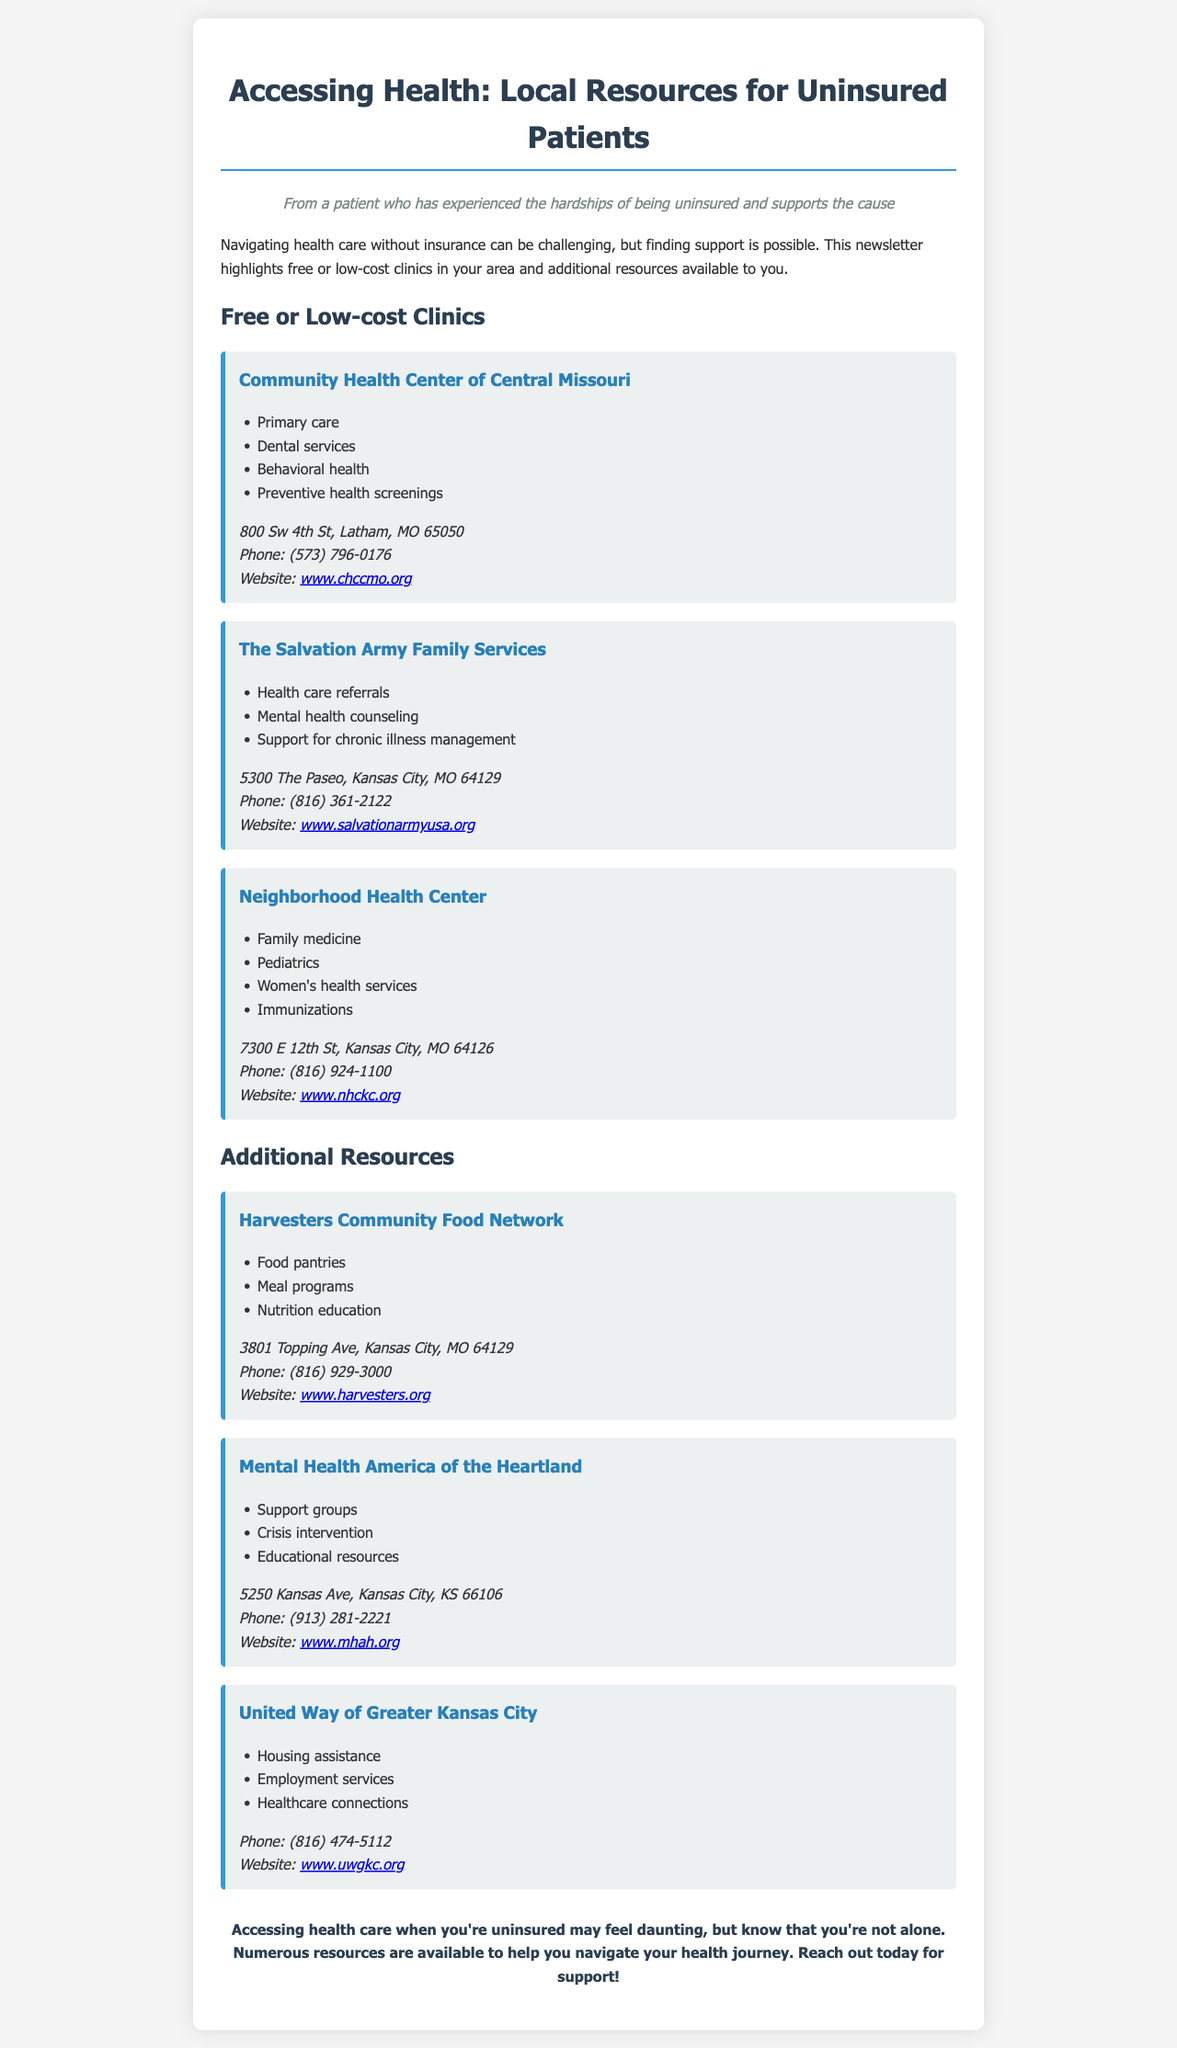what is the address of the Community Health Center of Central Missouri? The address is found in the contact information section of the document.
Answer: 800 Sw 4th St, Latham, MO 65050 what services does The Salvation Army Family Services provide? The services are listed under the clinic's description in the document.
Answer: Health care referrals, Mental health counseling, Support for chronic illness management what is the phone number for Neighborhood Health Center? The phone number is included under the contact information for the clinic.
Answer: (816) 924-1100 which organization offers food pantries? The service is identified in the section for additional resources.
Answer: Harvesters Community Food Network how many clinics are listed in the newsletter? This can be answered by counting the clinics mentioned in the section titled Free or Low-cost Clinics.
Answer: 3 what type of resources does United Way of Greater Kansas City provide? The document outlines several areas of assistance offered by the organization.
Answer: Housing assistance, Employment services, Healthcare connections what is the main theme of the newsletter? The theme is conveyed in the introduction and the closing statement of the document.
Answer: Accessing health care for uninsured patients where can I find more information about Mental Health America of the Heartland? The document provides contact details including website links under the resource section.
Answer: www.mhah.org what kind of educational initiatives does Harvesters Community Food Network offer? The initiatives are listed under its description in the additional resources section.
Answer: Nutrition education 